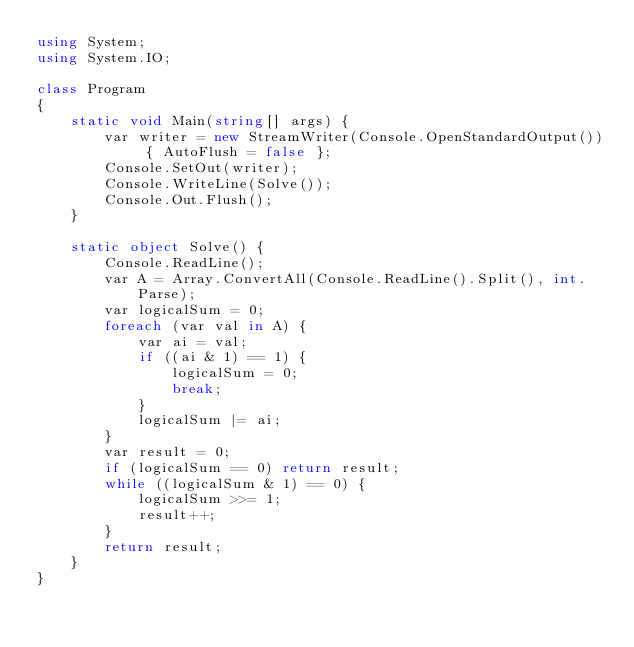<code> <loc_0><loc_0><loc_500><loc_500><_C#_>using System;
using System.IO;

class Program
{
    static void Main(string[] args) {
        var writer = new StreamWriter(Console.OpenStandardOutput()) { AutoFlush = false };
        Console.SetOut(writer);
        Console.WriteLine(Solve());
        Console.Out.Flush();
    }

    static object Solve() {
        Console.ReadLine();
        var A = Array.ConvertAll(Console.ReadLine().Split(), int.Parse);
        var logicalSum = 0;
        foreach (var val in A) {
            var ai = val;
            if ((ai & 1) == 1) {
                logicalSum = 0;
                break;
            }
            logicalSum |= ai;
        }
        var result = 0;
        if (logicalSum == 0) return result;
        while ((logicalSum & 1) == 0) {
            logicalSum >>= 1;
            result++;
        }
        return result;
    }
}</code> 